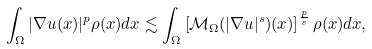<formula> <loc_0><loc_0><loc_500><loc_500>\int _ { \Omega } | \nabla u ( x ) | ^ { p } \rho ( x ) d x \lesssim \int _ { \Omega } \left [ \mathcal { M } _ { \Omega } ( | \nabla u | ^ { s } ) ( x ) \right ] ^ { \frac { p } { s } } \rho ( x ) d x ,</formula> 